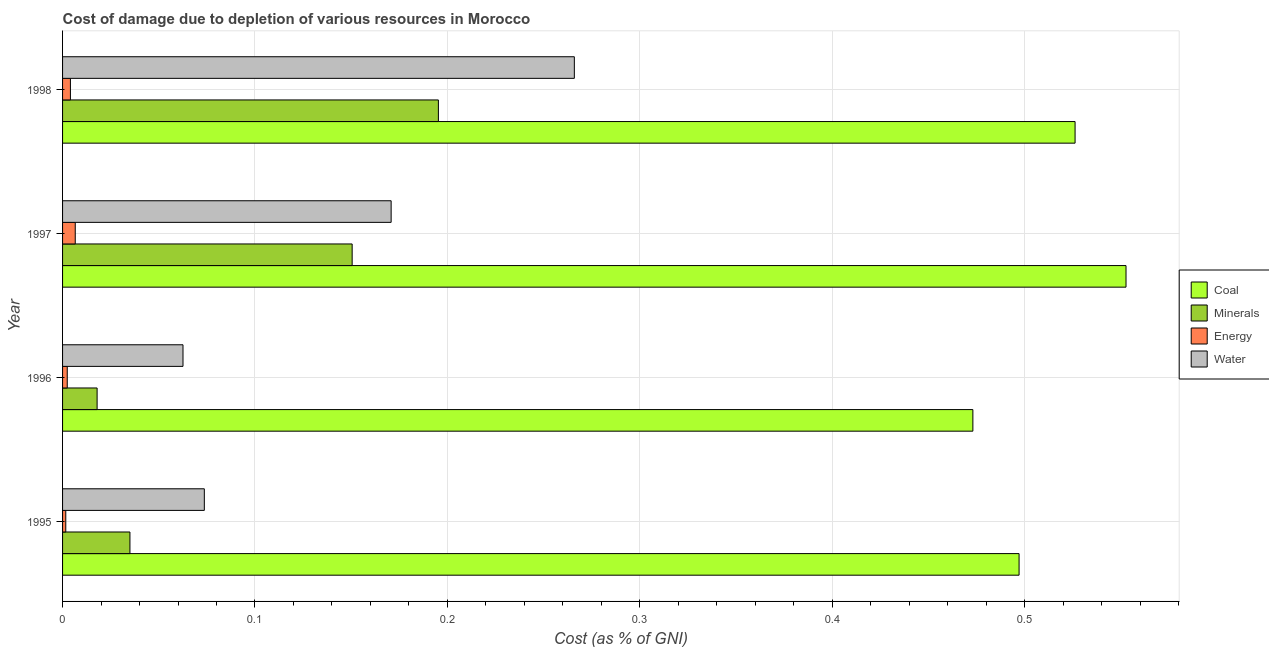What is the cost of damage due to depletion of water in 1995?
Your response must be concise. 0.07. Across all years, what is the maximum cost of damage due to depletion of energy?
Your answer should be compact. 0.01. Across all years, what is the minimum cost of damage due to depletion of coal?
Offer a terse response. 0.47. In which year was the cost of damage due to depletion of energy maximum?
Provide a succinct answer. 1997. What is the total cost of damage due to depletion of minerals in the graph?
Offer a very short reply. 0.4. What is the difference between the cost of damage due to depletion of minerals in 1997 and that in 1998?
Give a very brief answer. -0.04. What is the difference between the cost of damage due to depletion of energy in 1996 and the cost of damage due to depletion of minerals in 1998?
Your answer should be compact. -0.19. What is the average cost of damage due to depletion of coal per year?
Give a very brief answer. 0.51. In the year 1998, what is the difference between the cost of damage due to depletion of coal and cost of damage due to depletion of energy?
Make the answer very short. 0.52. What is the ratio of the cost of damage due to depletion of minerals in 1997 to that in 1998?
Make the answer very short. 0.77. Is the difference between the cost of damage due to depletion of minerals in 1995 and 1996 greater than the difference between the cost of damage due to depletion of water in 1995 and 1996?
Offer a terse response. Yes. What is the difference between the highest and the second highest cost of damage due to depletion of water?
Your answer should be very brief. 0.1. What is the difference between the highest and the lowest cost of damage due to depletion of energy?
Your answer should be very brief. 0. What does the 1st bar from the top in 1997 represents?
Your answer should be compact. Water. What does the 4th bar from the bottom in 1997 represents?
Keep it short and to the point. Water. Does the graph contain any zero values?
Offer a very short reply. No. What is the title of the graph?
Provide a short and direct response. Cost of damage due to depletion of various resources in Morocco . What is the label or title of the X-axis?
Give a very brief answer. Cost (as % of GNI). What is the Cost (as % of GNI) in Coal in 1995?
Your answer should be compact. 0.5. What is the Cost (as % of GNI) in Minerals in 1995?
Ensure brevity in your answer.  0.04. What is the Cost (as % of GNI) in Energy in 1995?
Ensure brevity in your answer.  0. What is the Cost (as % of GNI) of Water in 1995?
Your answer should be compact. 0.07. What is the Cost (as % of GNI) of Coal in 1996?
Give a very brief answer. 0.47. What is the Cost (as % of GNI) of Minerals in 1996?
Give a very brief answer. 0.02. What is the Cost (as % of GNI) in Energy in 1996?
Ensure brevity in your answer.  0. What is the Cost (as % of GNI) in Water in 1996?
Your answer should be compact. 0.06. What is the Cost (as % of GNI) in Coal in 1997?
Offer a very short reply. 0.55. What is the Cost (as % of GNI) in Minerals in 1997?
Give a very brief answer. 0.15. What is the Cost (as % of GNI) in Energy in 1997?
Provide a succinct answer. 0.01. What is the Cost (as % of GNI) in Water in 1997?
Provide a succinct answer. 0.17. What is the Cost (as % of GNI) of Coal in 1998?
Give a very brief answer. 0.53. What is the Cost (as % of GNI) in Minerals in 1998?
Your answer should be compact. 0.2. What is the Cost (as % of GNI) of Energy in 1998?
Keep it short and to the point. 0. What is the Cost (as % of GNI) in Water in 1998?
Give a very brief answer. 0.27. Across all years, what is the maximum Cost (as % of GNI) of Coal?
Your response must be concise. 0.55. Across all years, what is the maximum Cost (as % of GNI) of Minerals?
Your answer should be very brief. 0.2. Across all years, what is the maximum Cost (as % of GNI) in Energy?
Keep it short and to the point. 0.01. Across all years, what is the maximum Cost (as % of GNI) of Water?
Your answer should be compact. 0.27. Across all years, what is the minimum Cost (as % of GNI) in Coal?
Offer a terse response. 0.47. Across all years, what is the minimum Cost (as % of GNI) in Minerals?
Offer a terse response. 0.02. Across all years, what is the minimum Cost (as % of GNI) in Energy?
Offer a very short reply. 0. Across all years, what is the minimum Cost (as % of GNI) of Water?
Keep it short and to the point. 0.06. What is the total Cost (as % of GNI) in Coal in the graph?
Keep it short and to the point. 2.05. What is the total Cost (as % of GNI) in Minerals in the graph?
Your response must be concise. 0.4. What is the total Cost (as % of GNI) in Energy in the graph?
Make the answer very short. 0.01. What is the total Cost (as % of GNI) of Water in the graph?
Make the answer very short. 0.57. What is the difference between the Cost (as % of GNI) of Coal in 1995 and that in 1996?
Your answer should be very brief. 0.02. What is the difference between the Cost (as % of GNI) of Minerals in 1995 and that in 1996?
Your response must be concise. 0.02. What is the difference between the Cost (as % of GNI) in Energy in 1995 and that in 1996?
Your answer should be very brief. -0. What is the difference between the Cost (as % of GNI) in Water in 1995 and that in 1996?
Provide a short and direct response. 0.01. What is the difference between the Cost (as % of GNI) of Coal in 1995 and that in 1997?
Provide a succinct answer. -0.06. What is the difference between the Cost (as % of GNI) in Minerals in 1995 and that in 1997?
Provide a short and direct response. -0.12. What is the difference between the Cost (as % of GNI) of Energy in 1995 and that in 1997?
Provide a short and direct response. -0. What is the difference between the Cost (as % of GNI) of Water in 1995 and that in 1997?
Offer a terse response. -0.1. What is the difference between the Cost (as % of GNI) in Coal in 1995 and that in 1998?
Your answer should be very brief. -0.03. What is the difference between the Cost (as % of GNI) of Minerals in 1995 and that in 1998?
Offer a very short reply. -0.16. What is the difference between the Cost (as % of GNI) in Energy in 1995 and that in 1998?
Keep it short and to the point. -0. What is the difference between the Cost (as % of GNI) in Water in 1995 and that in 1998?
Provide a succinct answer. -0.19. What is the difference between the Cost (as % of GNI) in Coal in 1996 and that in 1997?
Make the answer very short. -0.08. What is the difference between the Cost (as % of GNI) in Minerals in 1996 and that in 1997?
Provide a succinct answer. -0.13. What is the difference between the Cost (as % of GNI) in Energy in 1996 and that in 1997?
Your response must be concise. -0. What is the difference between the Cost (as % of GNI) of Water in 1996 and that in 1997?
Provide a short and direct response. -0.11. What is the difference between the Cost (as % of GNI) of Coal in 1996 and that in 1998?
Offer a very short reply. -0.05. What is the difference between the Cost (as % of GNI) of Minerals in 1996 and that in 1998?
Offer a terse response. -0.18. What is the difference between the Cost (as % of GNI) in Energy in 1996 and that in 1998?
Make the answer very short. -0. What is the difference between the Cost (as % of GNI) of Water in 1996 and that in 1998?
Your response must be concise. -0.2. What is the difference between the Cost (as % of GNI) of Coal in 1997 and that in 1998?
Keep it short and to the point. 0.03. What is the difference between the Cost (as % of GNI) in Minerals in 1997 and that in 1998?
Ensure brevity in your answer.  -0.04. What is the difference between the Cost (as % of GNI) of Energy in 1997 and that in 1998?
Provide a succinct answer. 0. What is the difference between the Cost (as % of GNI) in Water in 1997 and that in 1998?
Provide a short and direct response. -0.1. What is the difference between the Cost (as % of GNI) in Coal in 1995 and the Cost (as % of GNI) in Minerals in 1996?
Offer a terse response. 0.48. What is the difference between the Cost (as % of GNI) in Coal in 1995 and the Cost (as % of GNI) in Energy in 1996?
Provide a succinct answer. 0.49. What is the difference between the Cost (as % of GNI) of Coal in 1995 and the Cost (as % of GNI) of Water in 1996?
Keep it short and to the point. 0.43. What is the difference between the Cost (as % of GNI) of Minerals in 1995 and the Cost (as % of GNI) of Energy in 1996?
Make the answer very short. 0.03. What is the difference between the Cost (as % of GNI) in Minerals in 1995 and the Cost (as % of GNI) in Water in 1996?
Provide a succinct answer. -0.03. What is the difference between the Cost (as % of GNI) in Energy in 1995 and the Cost (as % of GNI) in Water in 1996?
Offer a terse response. -0.06. What is the difference between the Cost (as % of GNI) of Coal in 1995 and the Cost (as % of GNI) of Minerals in 1997?
Your answer should be compact. 0.35. What is the difference between the Cost (as % of GNI) of Coal in 1995 and the Cost (as % of GNI) of Energy in 1997?
Provide a short and direct response. 0.49. What is the difference between the Cost (as % of GNI) of Coal in 1995 and the Cost (as % of GNI) of Water in 1997?
Your answer should be very brief. 0.33. What is the difference between the Cost (as % of GNI) in Minerals in 1995 and the Cost (as % of GNI) in Energy in 1997?
Provide a succinct answer. 0.03. What is the difference between the Cost (as % of GNI) of Minerals in 1995 and the Cost (as % of GNI) of Water in 1997?
Provide a succinct answer. -0.14. What is the difference between the Cost (as % of GNI) of Energy in 1995 and the Cost (as % of GNI) of Water in 1997?
Provide a short and direct response. -0.17. What is the difference between the Cost (as % of GNI) in Coal in 1995 and the Cost (as % of GNI) in Minerals in 1998?
Your answer should be compact. 0.3. What is the difference between the Cost (as % of GNI) in Coal in 1995 and the Cost (as % of GNI) in Energy in 1998?
Provide a short and direct response. 0.49. What is the difference between the Cost (as % of GNI) of Coal in 1995 and the Cost (as % of GNI) of Water in 1998?
Give a very brief answer. 0.23. What is the difference between the Cost (as % of GNI) of Minerals in 1995 and the Cost (as % of GNI) of Energy in 1998?
Make the answer very short. 0.03. What is the difference between the Cost (as % of GNI) of Minerals in 1995 and the Cost (as % of GNI) of Water in 1998?
Your answer should be very brief. -0.23. What is the difference between the Cost (as % of GNI) of Energy in 1995 and the Cost (as % of GNI) of Water in 1998?
Offer a terse response. -0.26. What is the difference between the Cost (as % of GNI) in Coal in 1996 and the Cost (as % of GNI) in Minerals in 1997?
Offer a terse response. 0.32. What is the difference between the Cost (as % of GNI) in Coal in 1996 and the Cost (as % of GNI) in Energy in 1997?
Provide a succinct answer. 0.47. What is the difference between the Cost (as % of GNI) of Coal in 1996 and the Cost (as % of GNI) of Water in 1997?
Your response must be concise. 0.3. What is the difference between the Cost (as % of GNI) of Minerals in 1996 and the Cost (as % of GNI) of Energy in 1997?
Provide a short and direct response. 0.01. What is the difference between the Cost (as % of GNI) in Minerals in 1996 and the Cost (as % of GNI) in Water in 1997?
Offer a terse response. -0.15. What is the difference between the Cost (as % of GNI) in Energy in 1996 and the Cost (as % of GNI) in Water in 1997?
Make the answer very short. -0.17. What is the difference between the Cost (as % of GNI) in Coal in 1996 and the Cost (as % of GNI) in Minerals in 1998?
Keep it short and to the point. 0.28. What is the difference between the Cost (as % of GNI) in Coal in 1996 and the Cost (as % of GNI) in Energy in 1998?
Provide a short and direct response. 0.47. What is the difference between the Cost (as % of GNI) of Coal in 1996 and the Cost (as % of GNI) of Water in 1998?
Provide a succinct answer. 0.21. What is the difference between the Cost (as % of GNI) in Minerals in 1996 and the Cost (as % of GNI) in Energy in 1998?
Provide a short and direct response. 0.01. What is the difference between the Cost (as % of GNI) of Minerals in 1996 and the Cost (as % of GNI) of Water in 1998?
Give a very brief answer. -0.25. What is the difference between the Cost (as % of GNI) of Energy in 1996 and the Cost (as % of GNI) of Water in 1998?
Your response must be concise. -0.26. What is the difference between the Cost (as % of GNI) in Coal in 1997 and the Cost (as % of GNI) in Minerals in 1998?
Give a very brief answer. 0.36. What is the difference between the Cost (as % of GNI) in Coal in 1997 and the Cost (as % of GNI) in Energy in 1998?
Keep it short and to the point. 0.55. What is the difference between the Cost (as % of GNI) in Coal in 1997 and the Cost (as % of GNI) in Water in 1998?
Provide a short and direct response. 0.29. What is the difference between the Cost (as % of GNI) of Minerals in 1997 and the Cost (as % of GNI) of Energy in 1998?
Offer a very short reply. 0.15. What is the difference between the Cost (as % of GNI) in Minerals in 1997 and the Cost (as % of GNI) in Water in 1998?
Your answer should be very brief. -0.12. What is the difference between the Cost (as % of GNI) of Energy in 1997 and the Cost (as % of GNI) of Water in 1998?
Give a very brief answer. -0.26. What is the average Cost (as % of GNI) in Coal per year?
Your response must be concise. 0.51. What is the average Cost (as % of GNI) in Minerals per year?
Make the answer very short. 0.1. What is the average Cost (as % of GNI) of Energy per year?
Your answer should be compact. 0. What is the average Cost (as % of GNI) of Water per year?
Provide a succinct answer. 0.14. In the year 1995, what is the difference between the Cost (as % of GNI) of Coal and Cost (as % of GNI) of Minerals?
Give a very brief answer. 0.46. In the year 1995, what is the difference between the Cost (as % of GNI) of Coal and Cost (as % of GNI) of Energy?
Offer a very short reply. 0.5. In the year 1995, what is the difference between the Cost (as % of GNI) of Coal and Cost (as % of GNI) of Water?
Keep it short and to the point. 0.42. In the year 1995, what is the difference between the Cost (as % of GNI) of Minerals and Cost (as % of GNI) of Water?
Offer a terse response. -0.04. In the year 1995, what is the difference between the Cost (as % of GNI) of Energy and Cost (as % of GNI) of Water?
Ensure brevity in your answer.  -0.07. In the year 1996, what is the difference between the Cost (as % of GNI) in Coal and Cost (as % of GNI) in Minerals?
Offer a terse response. 0.46. In the year 1996, what is the difference between the Cost (as % of GNI) of Coal and Cost (as % of GNI) of Energy?
Your answer should be compact. 0.47. In the year 1996, what is the difference between the Cost (as % of GNI) of Coal and Cost (as % of GNI) of Water?
Offer a terse response. 0.41. In the year 1996, what is the difference between the Cost (as % of GNI) of Minerals and Cost (as % of GNI) of Energy?
Offer a very short reply. 0.02. In the year 1996, what is the difference between the Cost (as % of GNI) in Minerals and Cost (as % of GNI) in Water?
Make the answer very short. -0.04. In the year 1996, what is the difference between the Cost (as % of GNI) of Energy and Cost (as % of GNI) of Water?
Keep it short and to the point. -0.06. In the year 1997, what is the difference between the Cost (as % of GNI) of Coal and Cost (as % of GNI) of Minerals?
Offer a terse response. 0.4. In the year 1997, what is the difference between the Cost (as % of GNI) in Coal and Cost (as % of GNI) in Energy?
Offer a very short reply. 0.55. In the year 1997, what is the difference between the Cost (as % of GNI) of Coal and Cost (as % of GNI) of Water?
Your answer should be compact. 0.38. In the year 1997, what is the difference between the Cost (as % of GNI) in Minerals and Cost (as % of GNI) in Energy?
Your response must be concise. 0.14. In the year 1997, what is the difference between the Cost (as % of GNI) in Minerals and Cost (as % of GNI) in Water?
Your answer should be very brief. -0.02. In the year 1997, what is the difference between the Cost (as % of GNI) of Energy and Cost (as % of GNI) of Water?
Provide a short and direct response. -0.16. In the year 1998, what is the difference between the Cost (as % of GNI) in Coal and Cost (as % of GNI) in Minerals?
Keep it short and to the point. 0.33. In the year 1998, what is the difference between the Cost (as % of GNI) of Coal and Cost (as % of GNI) of Energy?
Your answer should be very brief. 0.52. In the year 1998, what is the difference between the Cost (as % of GNI) in Coal and Cost (as % of GNI) in Water?
Offer a terse response. 0.26. In the year 1998, what is the difference between the Cost (as % of GNI) of Minerals and Cost (as % of GNI) of Energy?
Your answer should be very brief. 0.19. In the year 1998, what is the difference between the Cost (as % of GNI) of Minerals and Cost (as % of GNI) of Water?
Your response must be concise. -0.07. In the year 1998, what is the difference between the Cost (as % of GNI) in Energy and Cost (as % of GNI) in Water?
Your answer should be compact. -0.26. What is the ratio of the Cost (as % of GNI) in Coal in 1995 to that in 1996?
Give a very brief answer. 1.05. What is the ratio of the Cost (as % of GNI) in Minerals in 1995 to that in 1996?
Your response must be concise. 1.95. What is the ratio of the Cost (as % of GNI) in Energy in 1995 to that in 1996?
Offer a terse response. 0.68. What is the ratio of the Cost (as % of GNI) in Water in 1995 to that in 1996?
Your answer should be very brief. 1.18. What is the ratio of the Cost (as % of GNI) of Coal in 1995 to that in 1997?
Your response must be concise. 0.9. What is the ratio of the Cost (as % of GNI) of Minerals in 1995 to that in 1997?
Give a very brief answer. 0.23. What is the ratio of the Cost (as % of GNI) in Energy in 1995 to that in 1997?
Provide a short and direct response. 0.25. What is the ratio of the Cost (as % of GNI) in Water in 1995 to that in 1997?
Provide a succinct answer. 0.43. What is the ratio of the Cost (as % of GNI) of Coal in 1995 to that in 1998?
Ensure brevity in your answer.  0.94. What is the ratio of the Cost (as % of GNI) of Minerals in 1995 to that in 1998?
Your answer should be very brief. 0.18. What is the ratio of the Cost (as % of GNI) in Energy in 1995 to that in 1998?
Your answer should be compact. 0.41. What is the ratio of the Cost (as % of GNI) of Water in 1995 to that in 1998?
Give a very brief answer. 0.28. What is the ratio of the Cost (as % of GNI) in Coal in 1996 to that in 1997?
Your answer should be very brief. 0.86. What is the ratio of the Cost (as % of GNI) of Minerals in 1996 to that in 1997?
Your answer should be compact. 0.12. What is the ratio of the Cost (as % of GNI) of Energy in 1996 to that in 1997?
Your response must be concise. 0.37. What is the ratio of the Cost (as % of GNI) of Water in 1996 to that in 1997?
Ensure brevity in your answer.  0.37. What is the ratio of the Cost (as % of GNI) in Coal in 1996 to that in 1998?
Make the answer very short. 0.9. What is the ratio of the Cost (as % of GNI) in Minerals in 1996 to that in 1998?
Ensure brevity in your answer.  0.09. What is the ratio of the Cost (as % of GNI) of Energy in 1996 to that in 1998?
Your answer should be very brief. 0.6. What is the ratio of the Cost (as % of GNI) of Water in 1996 to that in 1998?
Offer a terse response. 0.24. What is the ratio of the Cost (as % of GNI) of Coal in 1997 to that in 1998?
Ensure brevity in your answer.  1.05. What is the ratio of the Cost (as % of GNI) of Minerals in 1997 to that in 1998?
Your response must be concise. 0.77. What is the ratio of the Cost (as % of GNI) in Energy in 1997 to that in 1998?
Your response must be concise. 1.62. What is the ratio of the Cost (as % of GNI) in Water in 1997 to that in 1998?
Give a very brief answer. 0.64. What is the difference between the highest and the second highest Cost (as % of GNI) in Coal?
Your response must be concise. 0.03. What is the difference between the highest and the second highest Cost (as % of GNI) of Minerals?
Your answer should be compact. 0.04. What is the difference between the highest and the second highest Cost (as % of GNI) of Energy?
Provide a succinct answer. 0. What is the difference between the highest and the second highest Cost (as % of GNI) in Water?
Provide a succinct answer. 0.1. What is the difference between the highest and the lowest Cost (as % of GNI) of Coal?
Make the answer very short. 0.08. What is the difference between the highest and the lowest Cost (as % of GNI) of Minerals?
Provide a succinct answer. 0.18. What is the difference between the highest and the lowest Cost (as % of GNI) of Energy?
Provide a succinct answer. 0. What is the difference between the highest and the lowest Cost (as % of GNI) of Water?
Keep it short and to the point. 0.2. 